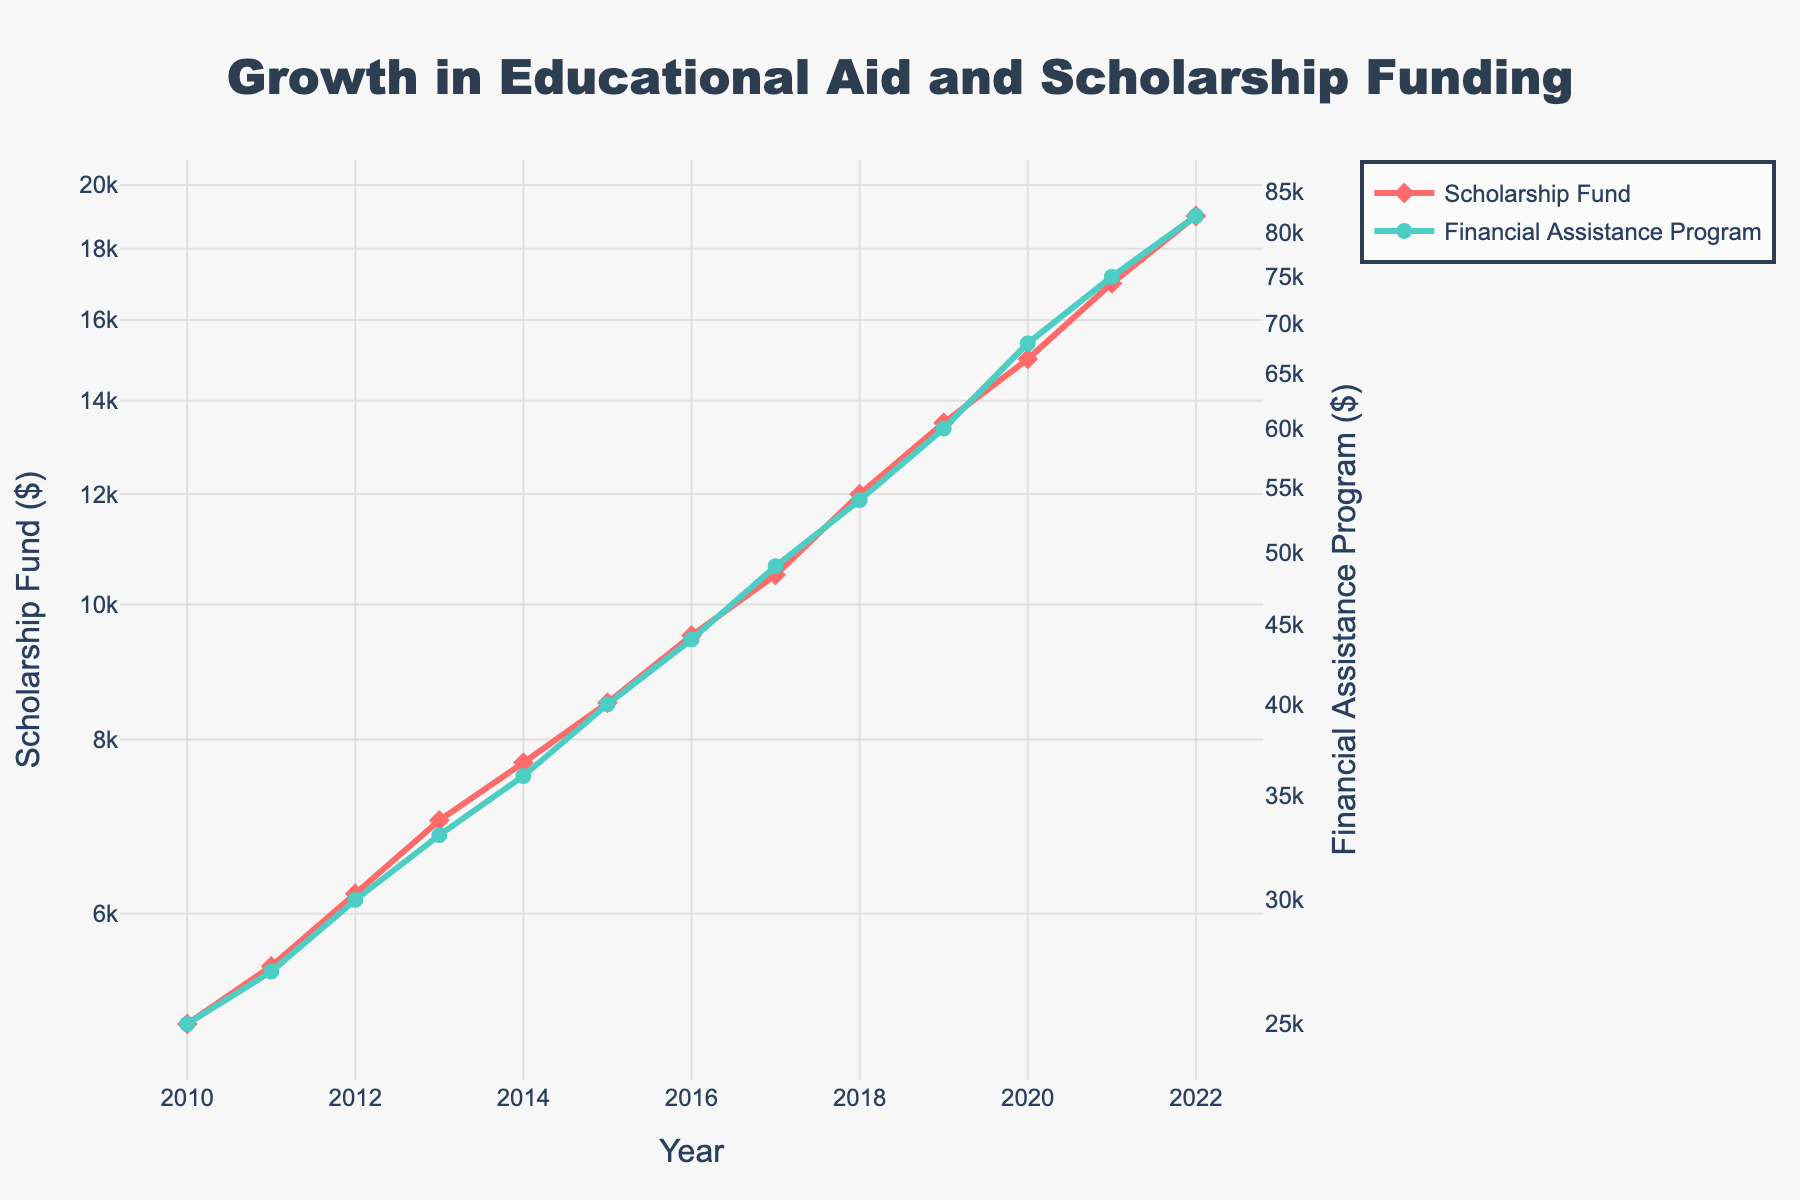what is the title of the plot? The title is located at the top of the plot. It summarizes the main topic of the plot. From the description, it reads: "Growth in Educational Aid and Scholarship Funding."
Answer: Growth in Educational Aid and Scholarship Funding What time period does the plot cover? The x-axis shows the years. By looking at the points on the x-axis, the time period covered by the plot is from 2010 to 2022.
Answer: 2010 to 2022 How many data points are shown for the Financial Assistance Program? Each year has a corresponding data point. Counting the years from 2010 to 2022, there are 13 points/data entries.
Answer: 13 Which year saw the highest amount for the Scholarship Fund? The y-axis for the Scholarship Fund shows the amounts over the years. The highest data point appears at the end, corresponding to the year 2022.
Answer: 2022 By how much did the Financial Assistance Program increase from 2010 to 2022? Find the amounts for both years: $25,000 in 2010 and $82,000 in 2022. The increase is $82,000 - $25,000.
Answer: $57,000 What is the color of the line representing the Scholarship Fund? The legend and the line on the graph indicate the color. It is a shade of red.
Answer: Red What's the difference between the Scholarship Fund and the Financial Assistance Program in 2017? For 2017, the Scholarship Fund is $10,500 and the Financial Assistance Program is $49,000. The difference is $49,000 - $10,500.
Answer: $38,500 Did the Financial Assistance Program grow faster or slower than the Scholarship Fund between 2010 and 2022? Both grew, but comparing the lines' slopes and starting and ending points, the Financial Assistance Program shows a greater increase. From $25,000 to $82,000 (+$57,000), and the Scholarship Fund from $5,000 to $19,000 (+$14,000), the Financial Assistance Program grew faster.
Answer: Financial Assistance Program grew faster In which year did the Scholarship Fund exceed $10,000? Check the y-axis values and corresponding years. It happened in 2017, when the Scholarship Fund reached $10,500.
Answer: 2017 What is the log scale used on the y-axes intended to show? The log scale transforms the data to assist in visualizing large ranges of values. It helps to display exponential growth more effectively.
Answer: Exponential growth 